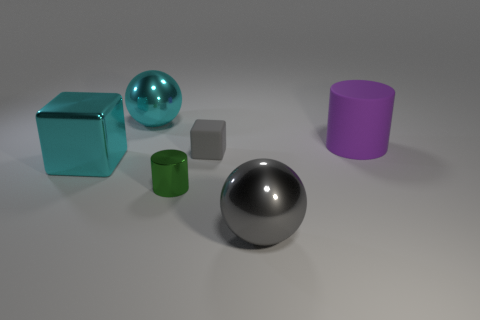Subtract all red spheres. Subtract all yellow cylinders. How many spheres are left? 2 Add 4 purple shiny cylinders. How many objects exist? 10 Subtract all blocks. How many objects are left? 4 Subtract 1 cyan spheres. How many objects are left? 5 Subtract all large cyan balls. Subtract all metallic spheres. How many objects are left? 3 Add 5 big purple rubber things. How many big purple rubber things are left? 6 Add 4 tiny blue cubes. How many tiny blue cubes exist? 4 